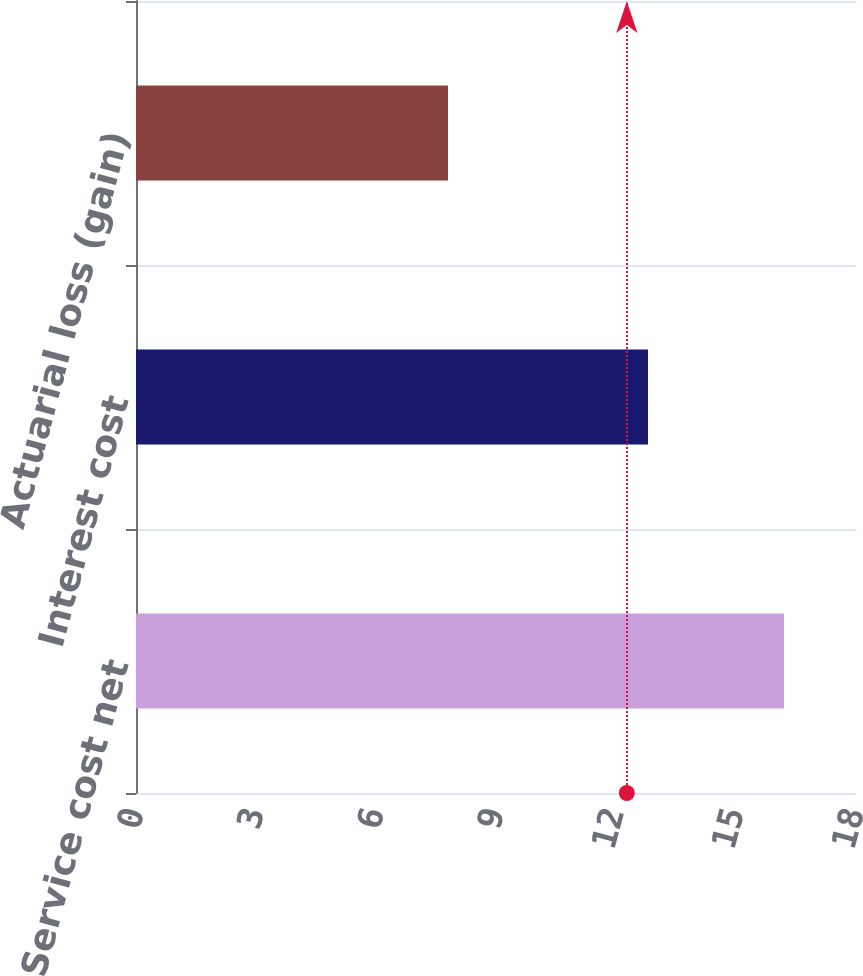Convert chart to OTSL. <chart><loc_0><loc_0><loc_500><loc_500><bar_chart><fcel>Service cost net<fcel>Interest cost<fcel>Actuarial loss (gain)<nl><fcel>16.2<fcel>12.8<fcel>7.8<nl></chart> 